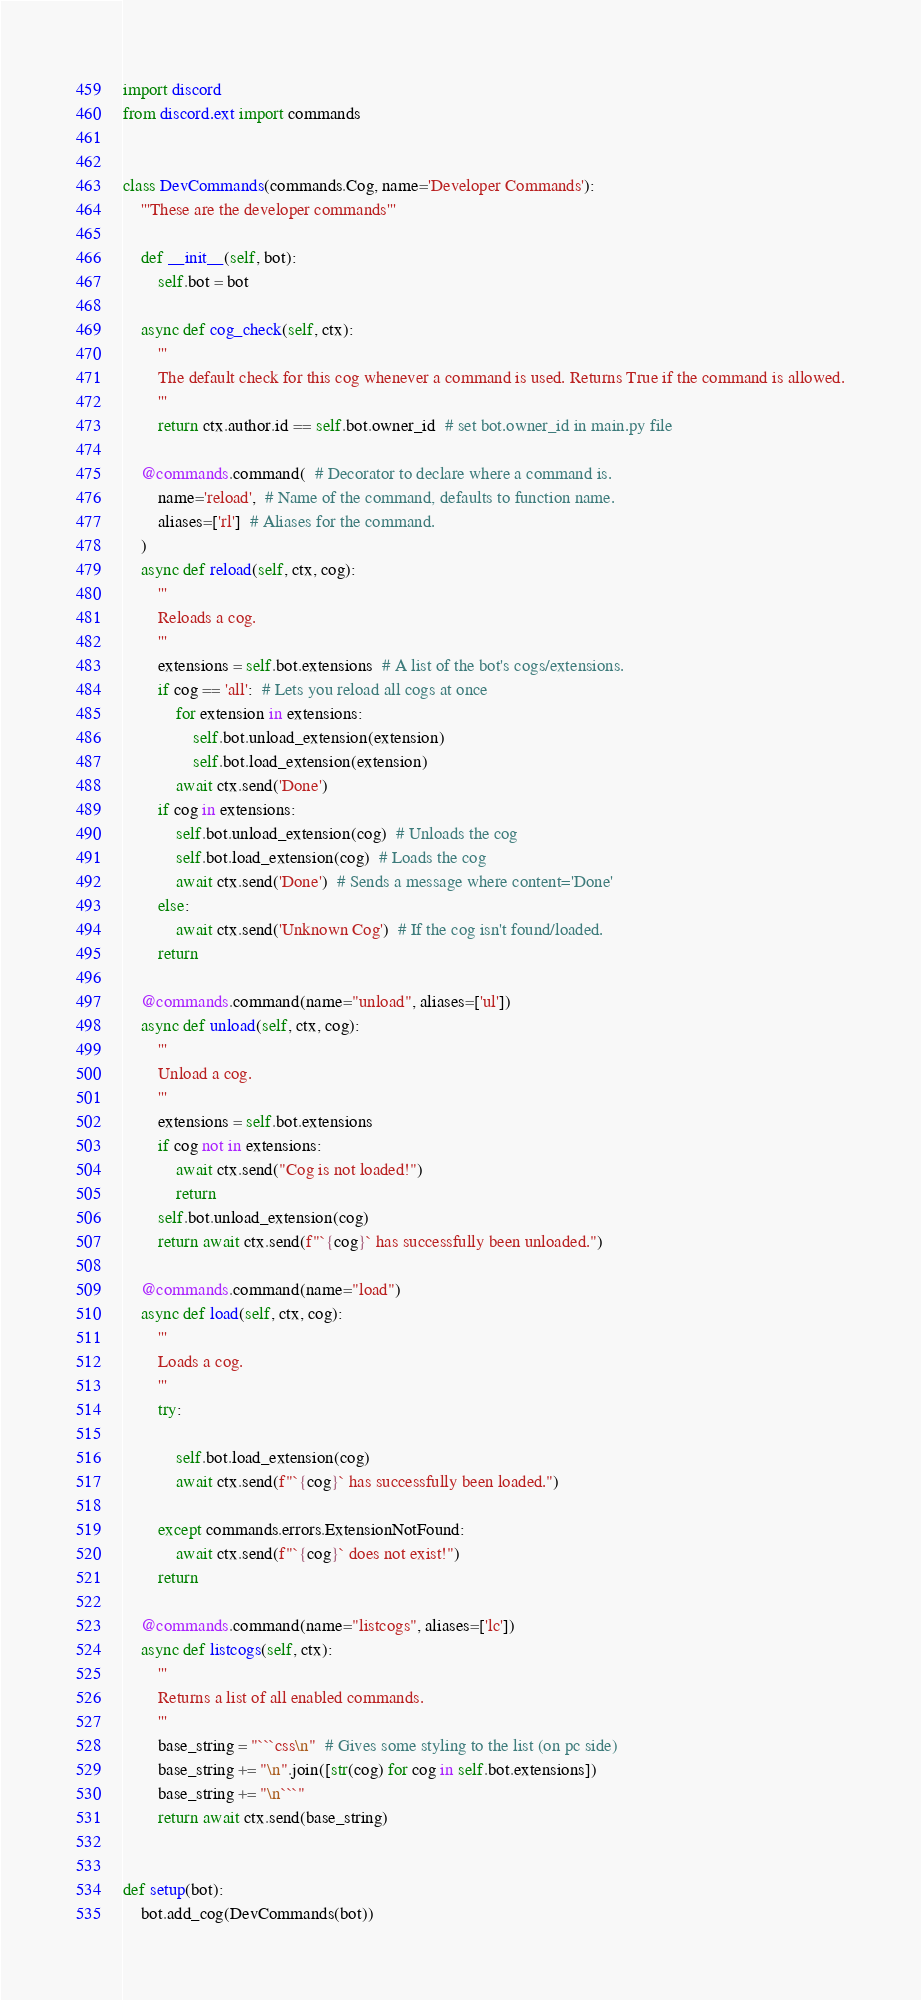Convert code to text. <code><loc_0><loc_0><loc_500><loc_500><_Python_>import discord
from discord.ext import commands


class DevCommands(commands.Cog, name='Developer Commands'):
	'''These are the developer commands'''

	def __init__(self, bot):
		self.bot = bot

	async def cog_check(self, ctx):  
		'''
		The default check for this cog whenever a command is used. Returns True if the command is allowed.
		'''
		return ctx.author.id == self.bot.owner_id  # set bot.owner_id in main.py file 

	@commands.command(  # Decorator to declare where a command is.
		name='reload',  # Name of the command, defaults to function name.
		aliases=['rl']  # Aliases for the command.
	)  
	async def reload(self, ctx, cog):
		'''
		Reloads a cog.
		'''
		extensions = self.bot.extensions  # A list of the bot's cogs/extensions.
		if cog == 'all':  # Lets you reload all cogs at once
			for extension in extensions:
				self.bot.unload_extension(extension)
				self.bot.load_extension(extension)
			await ctx.send('Done')
		if cog in extensions:
			self.bot.unload_extension(cog)  # Unloads the cog
			self.bot.load_extension(cog)  # Loads the cog
			await ctx.send('Done')  # Sends a message where content='Done'
		else:
			await ctx.send('Unknown Cog')  # If the cog isn't found/loaded.
		return
	
	@commands.command(name="unload", aliases=['ul']) 
	async def unload(self, ctx, cog):
		'''
		Unload a cog.
		'''
		extensions = self.bot.extensions
		if cog not in extensions:
			await ctx.send("Cog is not loaded!")
			return
		self.bot.unload_extension(cog)
		return await ctx.send(f"`{cog}` has successfully been unloaded.")
	
	@commands.command(name="load")
	async def load(self, ctx, cog):
		'''
		Loads a cog.
		'''
		try:

			self.bot.load_extension(cog)
			await ctx.send(f"`{cog}` has successfully been loaded.")

		except commands.errors.ExtensionNotFound:
			await ctx.send(f"`{cog}` does not exist!")
		return

	@commands.command(name="listcogs", aliases=['lc'])
	async def listcogs(self, ctx):
		'''
		Returns a list of all enabled commands.
		'''
		base_string = "```css\n"  # Gives some styling to the list (on pc side)
		base_string += "\n".join([str(cog) for cog in self.bot.extensions])
		base_string += "\n```"
		return await ctx.send(base_string)


def setup(bot):
	bot.add_cog(DevCommands(bot))
</code> 